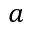Convert formula to latex. <formula><loc_0><loc_0><loc_500><loc_500>a</formula> 